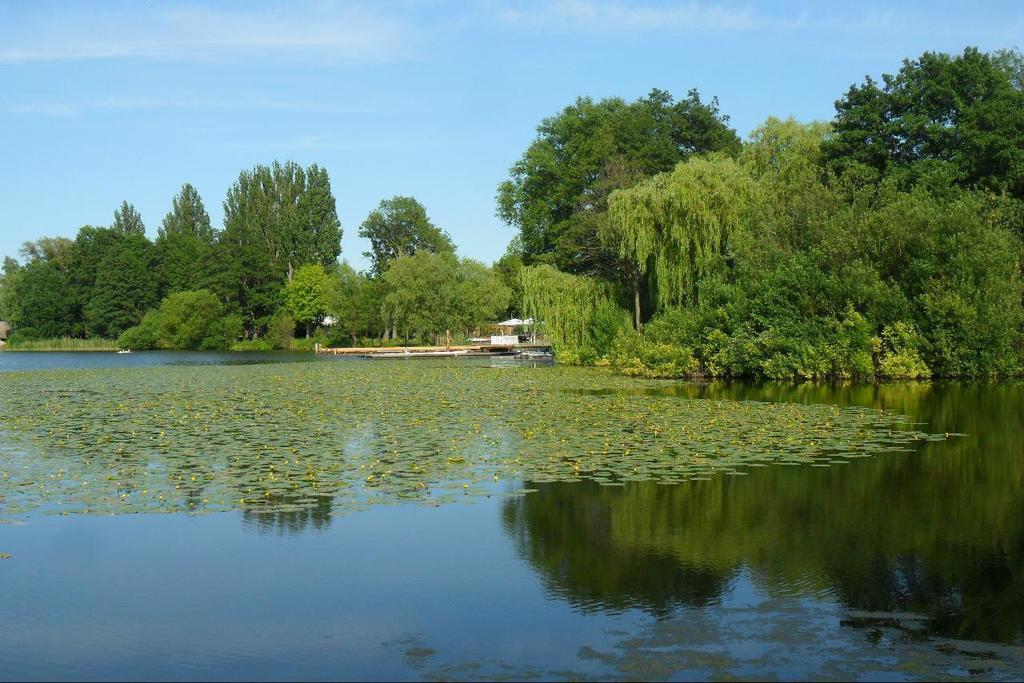Can you describe this image briefly? This image consists of water. In the background, there are many trees and plants. At the top, there is a sky. 